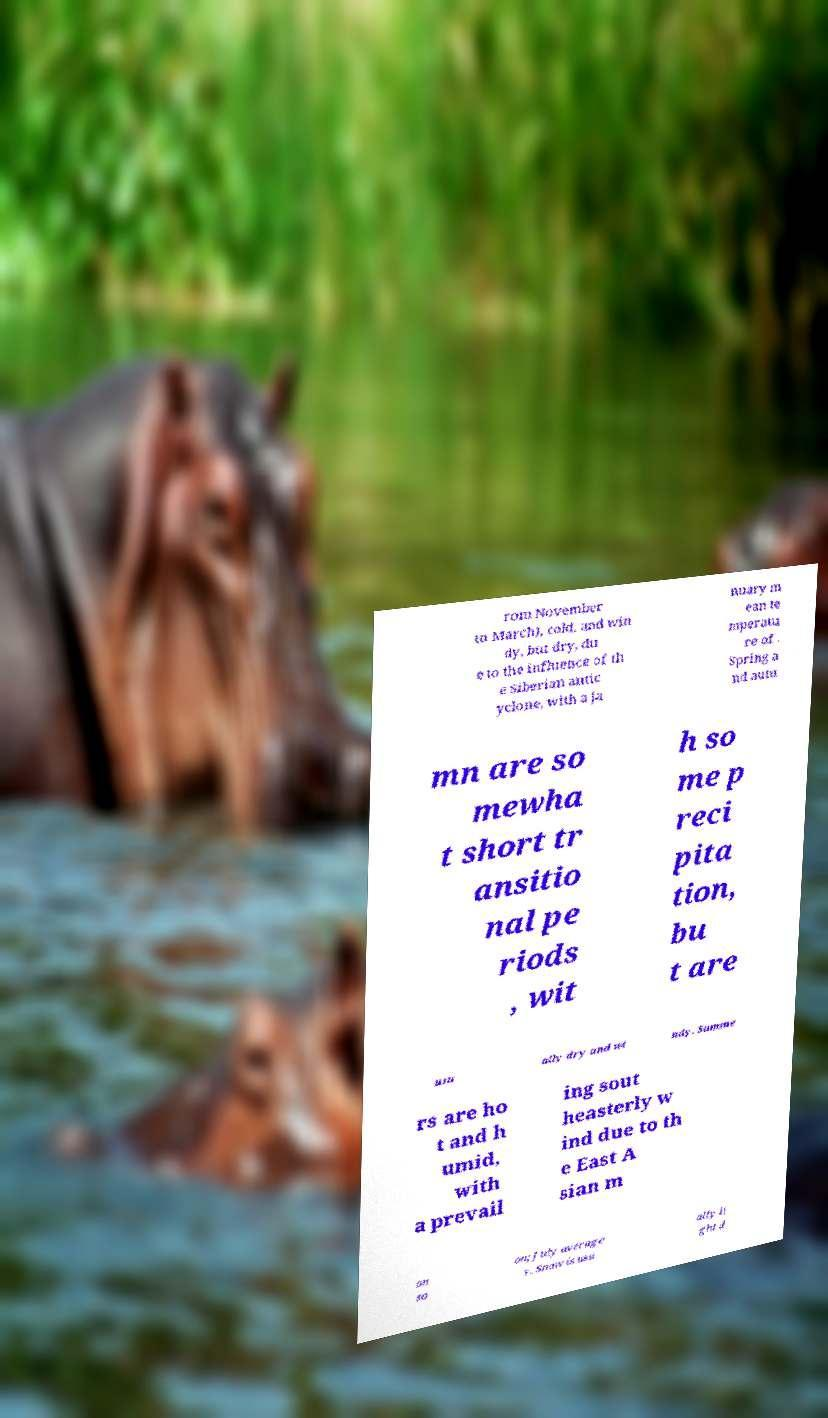For documentation purposes, I need the text within this image transcribed. Could you provide that? rom November to March), cold, and win dy, but dry, du e to the influence of th e Siberian antic yclone, with a Ja nuary m ean te mperatu re of . Spring a nd autu mn are so mewha t short tr ansitio nal pe riods , wit h so me p reci pita tion, bu t are usu ally dry and wi ndy. Summe rs are ho t and h umid, with a prevail ing sout heasterly w ind due to th e East A sian m on so on; July average s . Snow is usu ally li ght d 